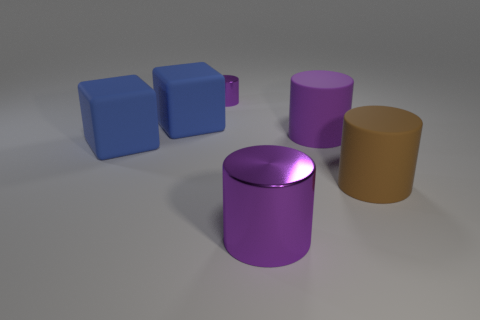Subtract all blue cubes. How many purple cylinders are left? 3 Add 3 green rubber balls. How many objects exist? 9 Subtract all blocks. How many objects are left? 4 Add 5 purple rubber things. How many purple rubber things exist? 6 Subtract 0 purple blocks. How many objects are left? 6 Subtract all large brown cylinders. Subtract all large blocks. How many objects are left? 3 Add 1 big metallic objects. How many big metallic objects are left? 2 